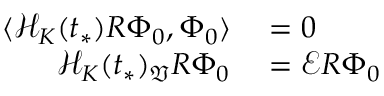<formula> <loc_0><loc_0><loc_500><loc_500>\begin{array} { r l } { \langle \mathcal { H } _ { K } ( t _ { * } ) R \Phi _ { 0 } , \Phi _ { 0 } \rangle } & = 0 } \\ { \mathcal { H } _ { K } ( t _ { * } ) _ { \mathfrak { V } } R \Phi _ { 0 } } & = \mathcal { E } R \Phi _ { 0 } } \end{array}</formula> 